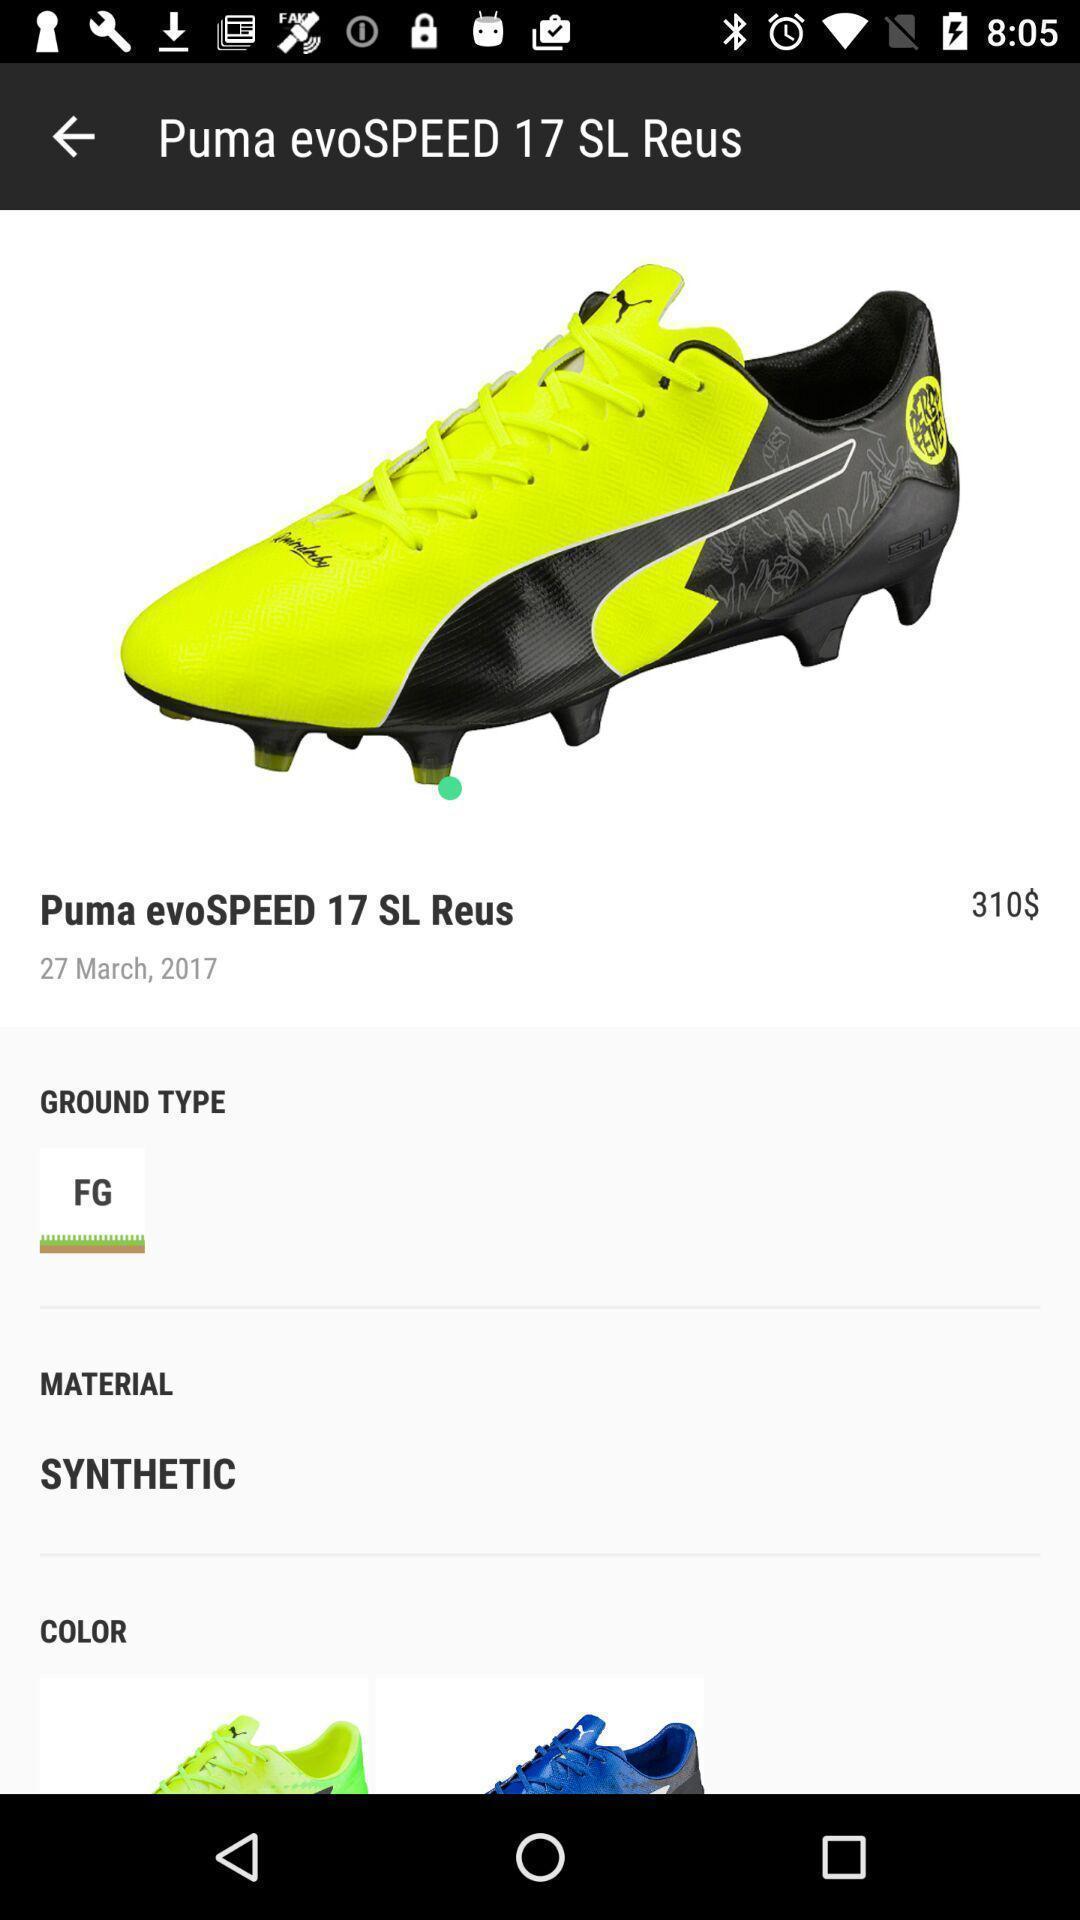Describe this image in words. Screen shows a product and details. 